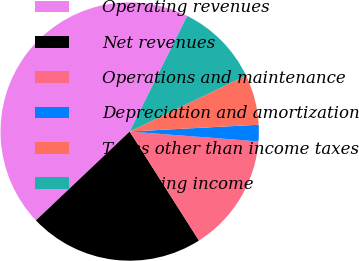<chart> <loc_0><loc_0><loc_500><loc_500><pie_chart><fcel>Operating revenues<fcel>Net revenues<fcel>Operations and maintenance<fcel>Depreciation and amortization<fcel>Taxes other than income taxes<fcel>Operating income<nl><fcel>44.42%<fcel>21.94%<fcel>14.77%<fcel>2.06%<fcel>6.29%<fcel>10.53%<nl></chart> 